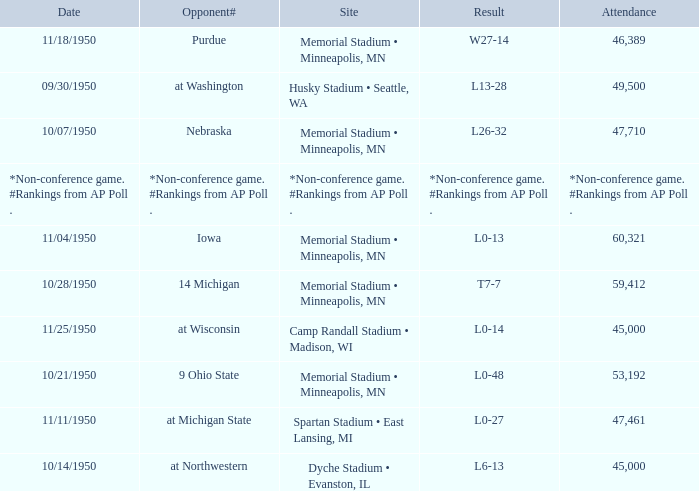What is the date when the opponent# is iowa? 11/04/1950. Would you mind parsing the complete table? {'header': ['Date', 'Opponent#', 'Site', 'Result', 'Attendance'], 'rows': [['11/18/1950', 'Purdue', 'Memorial Stadium • Minneapolis, MN', 'W27-14', '46,389'], ['09/30/1950', 'at Washington', 'Husky Stadium • Seattle, WA', 'L13-28', '49,500'], ['10/07/1950', 'Nebraska', 'Memorial Stadium • Minneapolis, MN', 'L26-32', '47,710'], ['*Non-conference game. #Rankings from AP Poll .', '*Non-conference game. #Rankings from AP Poll .', '*Non-conference game. #Rankings from AP Poll .', '*Non-conference game. #Rankings from AP Poll .', '*Non-conference game. #Rankings from AP Poll .'], ['11/04/1950', 'Iowa', 'Memorial Stadium • Minneapolis, MN', 'L0-13', '60,321'], ['10/28/1950', '14 Michigan', 'Memorial Stadium • Minneapolis, MN', 'T7-7', '59,412'], ['11/25/1950', 'at Wisconsin', 'Camp Randall Stadium • Madison, WI', 'L0-14', '45,000'], ['10/21/1950', '9 Ohio State', 'Memorial Stadium • Minneapolis, MN', 'L0-48', '53,192'], ['11/11/1950', 'at Michigan State', 'Spartan Stadium • East Lansing, MI', 'L0-27', '47,461'], ['10/14/1950', 'at Northwestern', 'Dyche Stadium • Evanston, IL', 'L6-13', '45,000']]} 